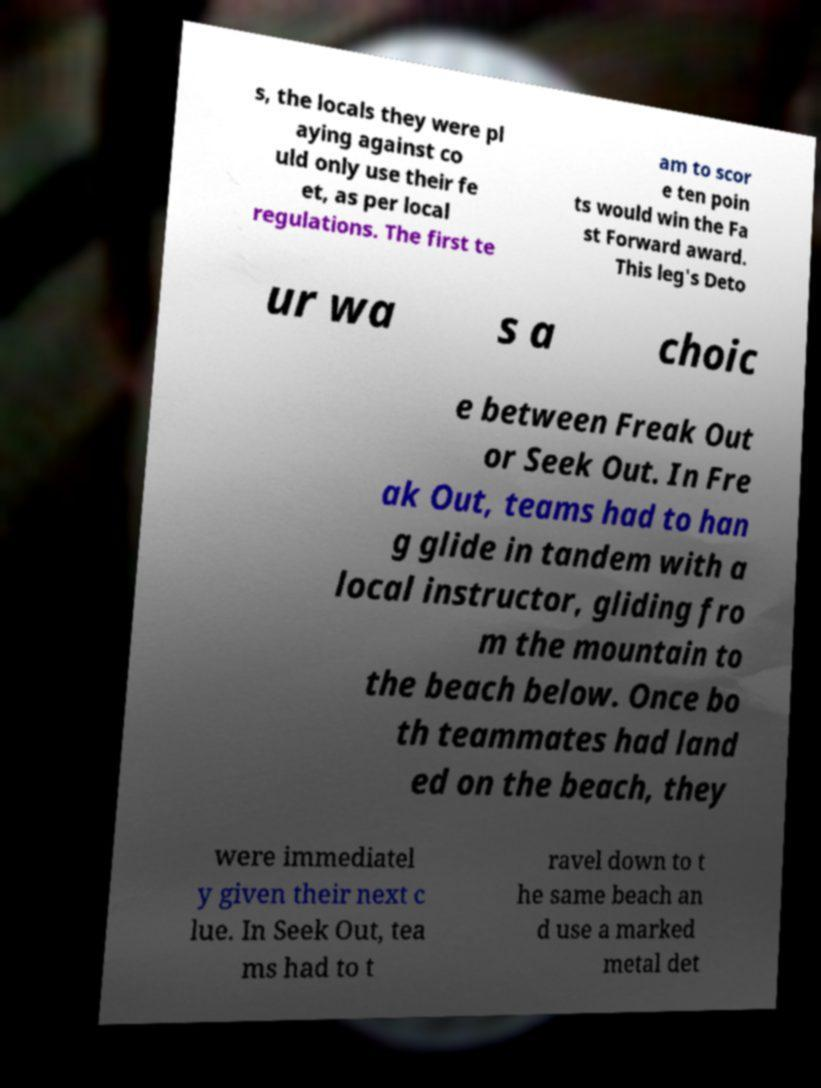There's text embedded in this image that I need extracted. Can you transcribe it verbatim? s, the locals they were pl aying against co uld only use their fe et, as per local regulations. The first te am to scor e ten poin ts would win the Fa st Forward award. This leg's Deto ur wa s a choic e between Freak Out or Seek Out. In Fre ak Out, teams had to han g glide in tandem with a local instructor, gliding fro m the mountain to the beach below. Once bo th teammates had land ed on the beach, they were immediatel y given their next c lue. In Seek Out, tea ms had to t ravel down to t he same beach an d use a marked metal det 